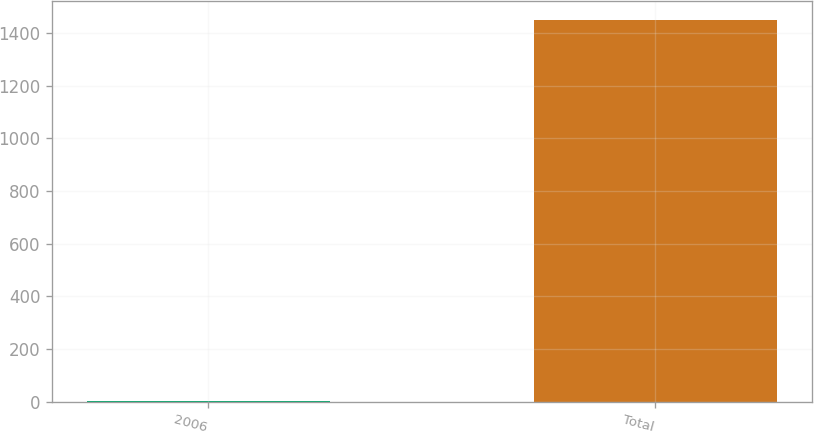<chart> <loc_0><loc_0><loc_500><loc_500><bar_chart><fcel>2006<fcel>Total<nl><fcel>2.1<fcel>1447.4<nl></chart> 